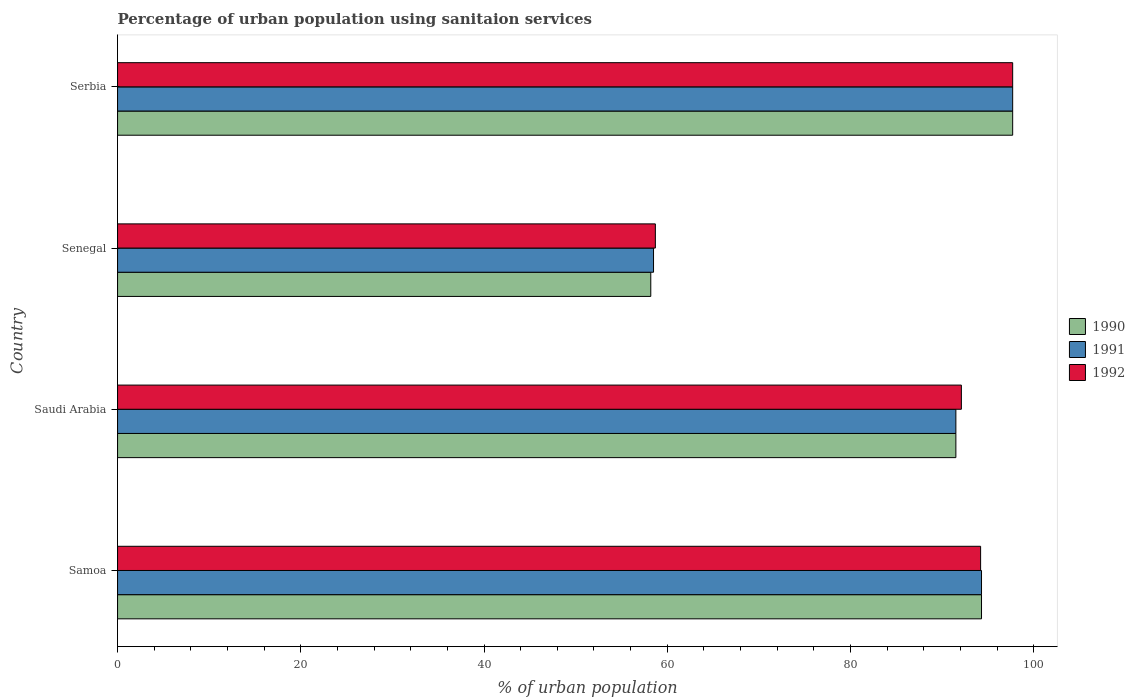How many groups of bars are there?
Provide a succinct answer. 4. Are the number of bars per tick equal to the number of legend labels?
Your answer should be very brief. Yes. Are the number of bars on each tick of the Y-axis equal?
Provide a short and direct response. Yes. How many bars are there on the 4th tick from the top?
Offer a very short reply. 3. How many bars are there on the 4th tick from the bottom?
Your response must be concise. 3. What is the label of the 1st group of bars from the top?
Your answer should be compact. Serbia. In how many cases, is the number of bars for a given country not equal to the number of legend labels?
Your response must be concise. 0. What is the percentage of urban population using sanitaion services in 1990 in Saudi Arabia?
Make the answer very short. 91.5. Across all countries, what is the maximum percentage of urban population using sanitaion services in 1992?
Give a very brief answer. 97.7. Across all countries, what is the minimum percentage of urban population using sanitaion services in 1990?
Provide a short and direct response. 58.2. In which country was the percentage of urban population using sanitaion services in 1991 maximum?
Offer a terse response. Serbia. In which country was the percentage of urban population using sanitaion services in 1992 minimum?
Your answer should be compact. Senegal. What is the total percentage of urban population using sanitaion services in 1992 in the graph?
Your response must be concise. 342.7. What is the difference between the percentage of urban population using sanitaion services in 1992 in Senegal and that in Serbia?
Your answer should be compact. -39. What is the difference between the percentage of urban population using sanitaion services in 1992 in Serbia and the percentage of urban population using sanitaion services in 1990 in Senegal?
Offer a very short reply. 39.5. What is the average percentage of urban population using sanitaion services in 1990 per country?
Offer a terse response. 85.42. What is the difference between the percentage of urban population using sanitaion services in 1992 and percentage of urban population using sanitaion services in 1991 in Senegal?
Provide a short and direct response. 0.2. In how many countries, is the percentage of urban population using sanitaion services in 1991 greater than 84 %?
Your response must be concise. 3. What is the ratio of the percentage of urban population using sanitaion services in 1992 in Senegal to that in Serbia?
Make the answer very short. 0.6. Is the percentage of urban population using sanitaion services in 1991 in Samoa less than that in Saudi Arabia?
Offer a terse response. No. Is the difference between the percentage of urban population using sanitaion services in 1992 in Saudi Arabia and Senegal greater than the difference between the percentage of urban population using sanitaion services in 1991 in Saudi Arabia and Senegal?
Make the answer very short. Yes. What is the difference between the highest and the second highest percentage of urban population using sanitaion services in 1991?
Offer a very short reply. 3.4. What is the difference between the highest and the lowest percentage of urban population using sanitaion services in 1992?
Provide a short and direct response. 39. In how many countries, is the percentage of urban population using sanitaion services in 1990 greater than the average percentage of urban population using sanitaion services in 1990 taken over all countries?
Your answer should be compact. 3. Is the sum of the percentage of urban population using sanitaion services in 1992 in Senegal and Serbia greater than the maximum percentage of urban population using sanitaion services in 1991 across all countries?
Your response must be concise. Yes. What does the 2nd bar from the top in Saudi Arabia represents?
Keep it short and to the point. 1991. What does the 3rd bar from the bottom in Samoa represents?
Make the answer very short. 1992. How many countries are there in the graph?
Make the answer very short. 4. What is the difference between two consecutive major ticks on the X-axis?
Your answer should be very brief. 20. Does the graph contain grids?
Give a very brief answer. No. Where does the legend appear in the graph?
Your response must be concise. Center right. How many legend labels are there?
Ensure brevity in your answer.  3. What is the title of the graph?
Offer a terse response. Percentage of urban population using sanitaion services. Does "1977" appear as one of the legend labels in the graph?
Your answer should be very brief. No. What is the label or title of the X-axis?
Keep it short and to the point. % of urban population. What is the % of urban population of 1990 in Samoa?
Provide a short and direct response. 94.3. What is the % of urban population of 1991 in Samoa?
Offer a terse response. 94.3. What is the % of urban population of 1992 in Samoa?
Your response must be concise. 94.2. What is the % of urban population in 1990 in Saudi Arabia?
Give a very brief answer. 91.5. What is the % of urban population of 1991 in Saudi Arabia?
Give a very brief answer. 91.5. What is the % of urban population in 1992 in Saudi Arabia?
Give a very brief answer. 92.1. What is the % of urban population of 1990 in Senegal?
Make the answer very short. 58.2. What is the % of urban population in 1991 in Senegal?
Provide a succinct answer. 58.5. What is the % of urban population in 1992 in Senegal?
Keep it short and to the point. 58.7. What is the % of urban population in 1990 in Serbia?
Offer a terse response. 97.7. What is the % of urban population in 1991 in Serbia?
Your answer should be compact. 97.7. What is the % of urban population in 1992 in Serbia?
Keep it short and to the point. 97.7. Across all countries, what is the maximum % of urban population in 1990?
Provide a short and direct response. 97.7. Across all countries, what is the maximum % of urban population in 1991?
Offer a very short reply. 97.7. Across all countries, what is the maximum % of urban population of 1992?
Your answer should be very brief. 97.7. Across all countries, what is the minimum % of urban population in 1990?
Give a very brief answer. 58.2. Across all countries, what is the minimum % of urban population in 1991?
Ensure brevity in your answer.  58.5. Across all countries, what is the minimum % of urban population of 1992?
Your answer should be compact. 58.7. What is the total % of urban population of 1990 in the graph?
Offer a very short reply. 341.7. What is the total % of urban population of 1991 in the graph?
Your answer should be very brief. 342. What is the total % of urban population in 1992 in the graph?
Provide a short and direct response. 342.7. What is the difference between the % of urban population in 1991 in Samoa and that in Saudi Arabia?
Give a very brief answer. 2.8. What is the difference between the % of urban population of 1992 in Samoa and that in Saudi Arabia?
Provide a short and direct response. 2.1. What is the difference between the % of urban population in 1990 in Samoa and that in Senegal?
Provide a short and direct response. 36.1. What is the difference between the % of urban population of 1991 in Samoa and that in Senegal?
Your answer should be compact. 35.8. What is the difference between the % of urban population in 1992 in Samoa and that in Senegal?
Give a very brief answer. 35.5. What is the difference between the % of urban population of 1990 in Samoa and that in Serbia?
Keep it short and to the point. -3.4. What is the difference between the % of urban population of 1992 in Samoa and that in Serbia?
Your response must be concise. -3.5. What is the difference between the % of urban population in 1990 in Saudi Arabia and that in Senegal?
Provide a short and direct response. 33.3. What is the difference between the % of urban population in 1992 in Saudi Arabia and that in Senegal?
Offer a terse response. 33.4. What is the difference between the % of urban population in 1990 in Saudi Arabia and that in Serbia?
Give a very brief answer. -6.2. What is the difference between the % of urban population in 1991 in Saudi Arabia and that in Serbia?
Provide a short and direct response. -6.2. What is the difference between the % of urban population in 1992 in Saudi Arabia and that in Serbia?
Give a very brief answer. -5.6. What is the difference between the % of urban population of 1990 in Senegal and that in Serbia?
Give a very brief answer. -39.5. What is the difference between the % of urban population of 1991 in Senegal and that in Serbia?
Provide a short and direct response. -39.2. What is the difference between the % of urban population in 1992 in Senegal and that in Serbia?
Keep it short and to the point. -39. What is the difference between the % of urban population of 1990 in Samoa and the % of urban population of 1991 in Saudi Arabia?
Ensure brevity in your answer.  2.8. What is the difference between the % of urban population of 1991 in Samoa and the % of urban population of 1992 in Saudi Arabia?
Your answer should be compact. 2.2. What is the difference between the % of urban population in 1990 in Samoa and the % of urban population in 1991 in Senegal?
Ensure brevity in your answer.  35.8. What is the difference between the % of urban population of 1990 in Samoa and the % of urban population of 1992 in Senegal?
Offer a very short reply. 35.6. What is the difference between the % of urban population of 1991 in Samoa and the % of urban population of 1992 in Senegal?
Your answer should be very brief. 35.6. What is the difference between the % of urban population of 1990 in Samoa and the % of urban population of 1992 in Serbia?
Your answer should be very brief. -3.4. What is the difference between the % of urban population in 1991 in Samoa and the % of urban population in 1992 in Serbia?
Your response must be concise. -3.4. What is the difference between the % of urban population of 1990 in Saudi Arabia and the % of urban population of 1991 in Senegal?
Make the answer very short. 33. What is the difference between the % of urban population of 1990 in Saudi Arabia and the % of urban population of 1992 in Senegal?
Your answer should be very brief. 32.8. What is the difference between the % of urban population in 1991 in Saudi Arabia and the % of urban population in 1992 in Senegal?
Provide a succinct answer. 32.8. What is the difference between the % of urban population of 1990 in Saudi Arabia and the % of urban population of 1991 in Serbia?
Your response must be concise. -6.2. What is the difference between the % of urban population in 1991 in Saudi Arabia and the % of urban population in 1992 in Serbia?
Ensure brevity in your answer.  -6.2. What is the difference between the % of urban population in 1990 in Senegal and the % of urban population in 1991 in Serbia?
Your response must be concise. -39.5. What is the difference between the % of urban population of 1990 in Senegal and the % of urban population of 1992 in Serbia?
Make the answer very short. -39.5. What is the difference between the % of urban population in 1991 in Senegal and the % of urban population in 1992 in Serbia?
Ensure brevity in your answer.  -39.2. What is the average % of urban population of 1990 per country?
Your response must be concise. 85.42. What is the average % of urban population in 1991 per country?
Keep it short and to the point. 85.5. What is the average % of urban population in 1992 per country?
Your response must be concise. 85.67. What is the difference between the % of urban population of 1990 and % of urban population of 1992 in Samoa?
Give a very brief answer. 0.1. What is the difference between the % of urban population of 1991 and % of urban population of 1992 in Saudi Arabia?
Ensure brevity in your answer.  -0.6. What is the difference between the % of urban population of 1991 and % of urban population of 1992 in Senegal?
Your response must be concise. -0.2. What is the difference between the % of urban population in 1991 and % of urban population in 1992 in Serbia?
Give a very brief answer. 0. What is the ratio of the % of urban population in 1990 in Samoa to that in Saudi Arabia?
Your response must be concise. 1.03. What is the ratio of the % of urban population of 1991 in Samoa to that in Saudi Arabia?
Keep it short and to the point. 1.03. What is the ratio of the % of urban population of 1992 in Samoa to that in Saudi Arabia?
Give a very brief answer. 1.02. What is the ratio of the % of urban population of 1990 in Samoa to that in Senegal?
Keep it short and to the point. 1.62. What is the ratio of the % of urban population of 1991 in Samoa to that in Senegal?
Offer a terse response. 1.61. What is the ratio of the % of urban population of 1992 in Samoa to that in Senegal?
Provide a succinct answer. 1.6. What is the ratio of the % of urban population of 1990 in Samoa to that in Serbia?
Make the answer very short. 0.97. What is the ratio of the % of urban population in 1991 in Samoa to that in Serbia?
Offer a terse response. 0.97. What is the ratio of the % of urban population in 1992 in Samoa to that in Serbia?
Your answer should be very brief. 0.96. What is the ratio of the % of urban population in 1990 in Saudi Arabia to that in Senegal?
Your response must be concise. 1.57. What is the ratio of the % of urban population of 1991 in Saudi Arabia to that in Senegal?
Offer a terse response. 1.56. What is the ratio of the % of urban population in 1992 in Saudi Arabia to that in Senegal?
Your answer should be compact. 1.57. What is the ratio of the % of urban population of 1990 in Saudi Arabia to that in Serbia?
Make the answer very short. 0.94. What is the ratio of the % of urban population of 1991 in Saudi Arabia to that in Serbia?
Offer a terse response. 0.94. What is the ratio of the % of urban population of 1992 in Saudi Arabia to that in Serbia?
Offer a terse response. 0.94. What is the ratio of the % of urban population in 1990 in Senegal to that in Serbia?
Your answer should be very brief. 0.6. What is the ratio of the % of urban population in 1991 in Senegal to that in Serbia?
Make the answer very short. 0.6. What is the ratio of the % of urban population of 1992 in Senegal to that in Serbia?
Keep it short and to the point. 0.6. What is the difference between the highest and the second highest % of urban population of 1990?
Offer a terse response. 3.4. What is the difference between the highest and the second highest % of urban population of 1992?
Give a very brief answer. 3.5. What is the difference between the highest and the lowest % of urban population of 1990?
Offer a terse response. 39.5. What is the difference between the highest and the lowest % of urban population of 1991?
Ensure brevity in your answer.  39.2. What is the difference between the highest and the lowest % of urban population of 1992?
Make the answer very short. 39. 